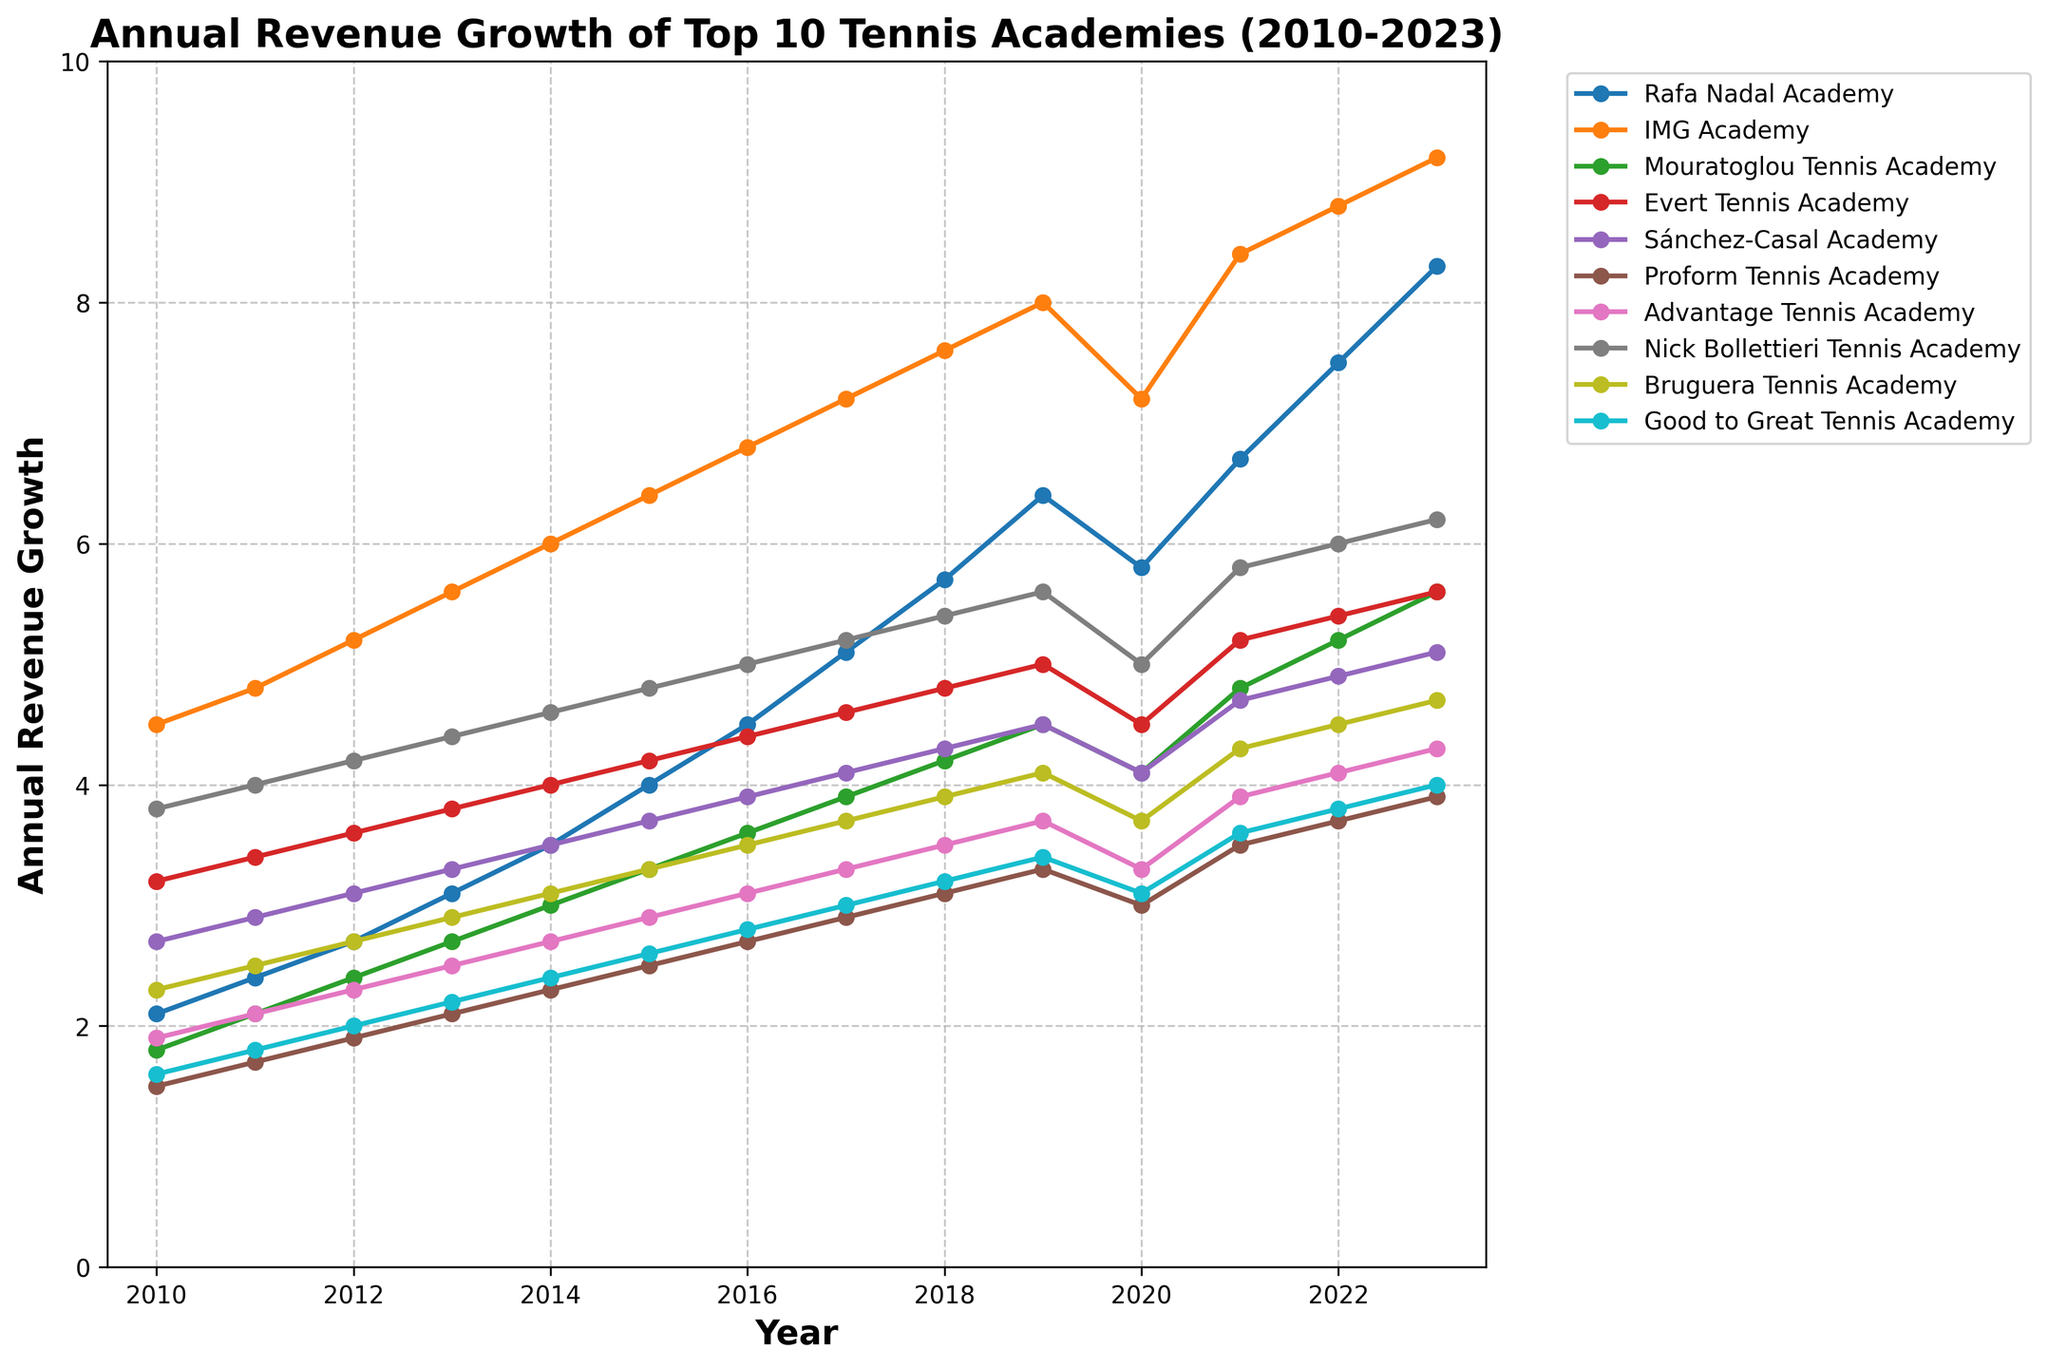What is the general trend of the Rafa Nadal Academy's revenue from 2010 to 2023? The line chart for the Rafa Nadal Academy shows a consistent increase in annual revenue from 2010 to 2023, starting from 2.1 in 2010 and rising to 8.3 in 2023.
Answer: Increasing Which tennis academy had the highest revenue growth in 2023? By comparing the final points on each line for 2023, the IMG Academy has the highest revenue growth at 9.2.
Answer: IMG Academy Between 2016 and 2017, which academy showed the greatest absolute increase in revenue? Subtract the 2016 revenue from the 2017 revenue for each academy and compare. Rafa Nadal Academy (5.1-4.5=0.6), IMG Academy (7.2-6.8=0.4), etc. Rafa Nadal Academy shows the greatest increase with 0.6.
Answer: Rafa Nadal Academy What is the average revenue growth for Good to Great Tennis Academy over the 14 years? Summing up the revenue values for Good to Great Tennis Academy from 2010 to 2023 (1.6 + 1.8 + 2.0 + 2.2 + 2.4 + 2.6 + 2.8 + 3.0 + 3.2 + 3.4 + 3.1 + 3.6 + 3.8 + 4.0) gives 41.5. Dividing by 14 years, the average is 41.5 / 14 ≈ 2.96.
Answer: 2.96 How did the revenues of Evert Tennis Academy change from 2019 to 2020? By examining the line chart, Evert Tennis Academy's revenue decreased from 5.0 in 2019 to 4.5 in 2020.
Answer: Decrease Which academies experienced a decline in their revenues between 2019 and 2020? For each academy, compare the 2019 and 2020 values. Rafa Nadal Academy (6.4 to 5.8), IMG Academy (8.0 to 7.2), Mouratoglou Tennis Academy (4.5 to 4.1), Evert Tennis Academy (5.0 to 4.5), Sánchez-Casal Academy (4.5 to 4.1), Proform Tennis Academy (3.3 to 3.0), and Good to Great Tennis Academy (3.4 to 3.1) all exhibited declines.
Answer: Rafa Nadal Academy, IMG Academy, Mouratoglou Tennis Academy, Evert Tennis Academy, Sánchez-Casal Academy, Proform Tennis Academy, Good to Great Tennis Academy Which year did the Nick Bollettieri Tennis Academy exhibit the highest growth rate in revenue compared to the previous year? By subtracting each previous year's revenue from the current year, the largest increase is identified. The largest difference occurs between 2010 to 2011 (4.0 - 3.8 = 0.2) and between 2020 to 2021 (5.8 - 5.0 = 0.8). The highest growth is in 2021.
Answer: 2021 